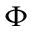<formula> <loc_0><loc_0><loc_500><loc_500>\Phi</formula> 